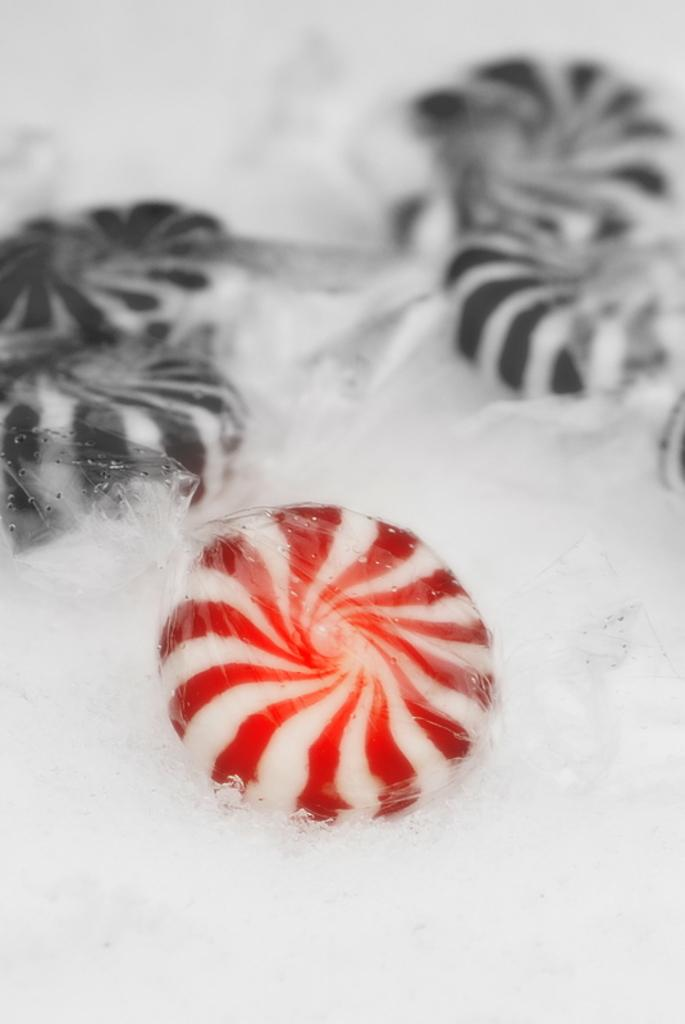What type of candy is in the foreground of the image? There is a red and white color candy in the foreground of the image. What colors are the candies in the background of the image? There are black and white color candies in the background of the image. Can you describe the white object at the bottom of the image? There is a white color object at the bottom of the image. What type of boot is visible in the image? There is no boot present in the image. How many books are stacked on the white object at the bottom of the image? There are no books visible in the image. 